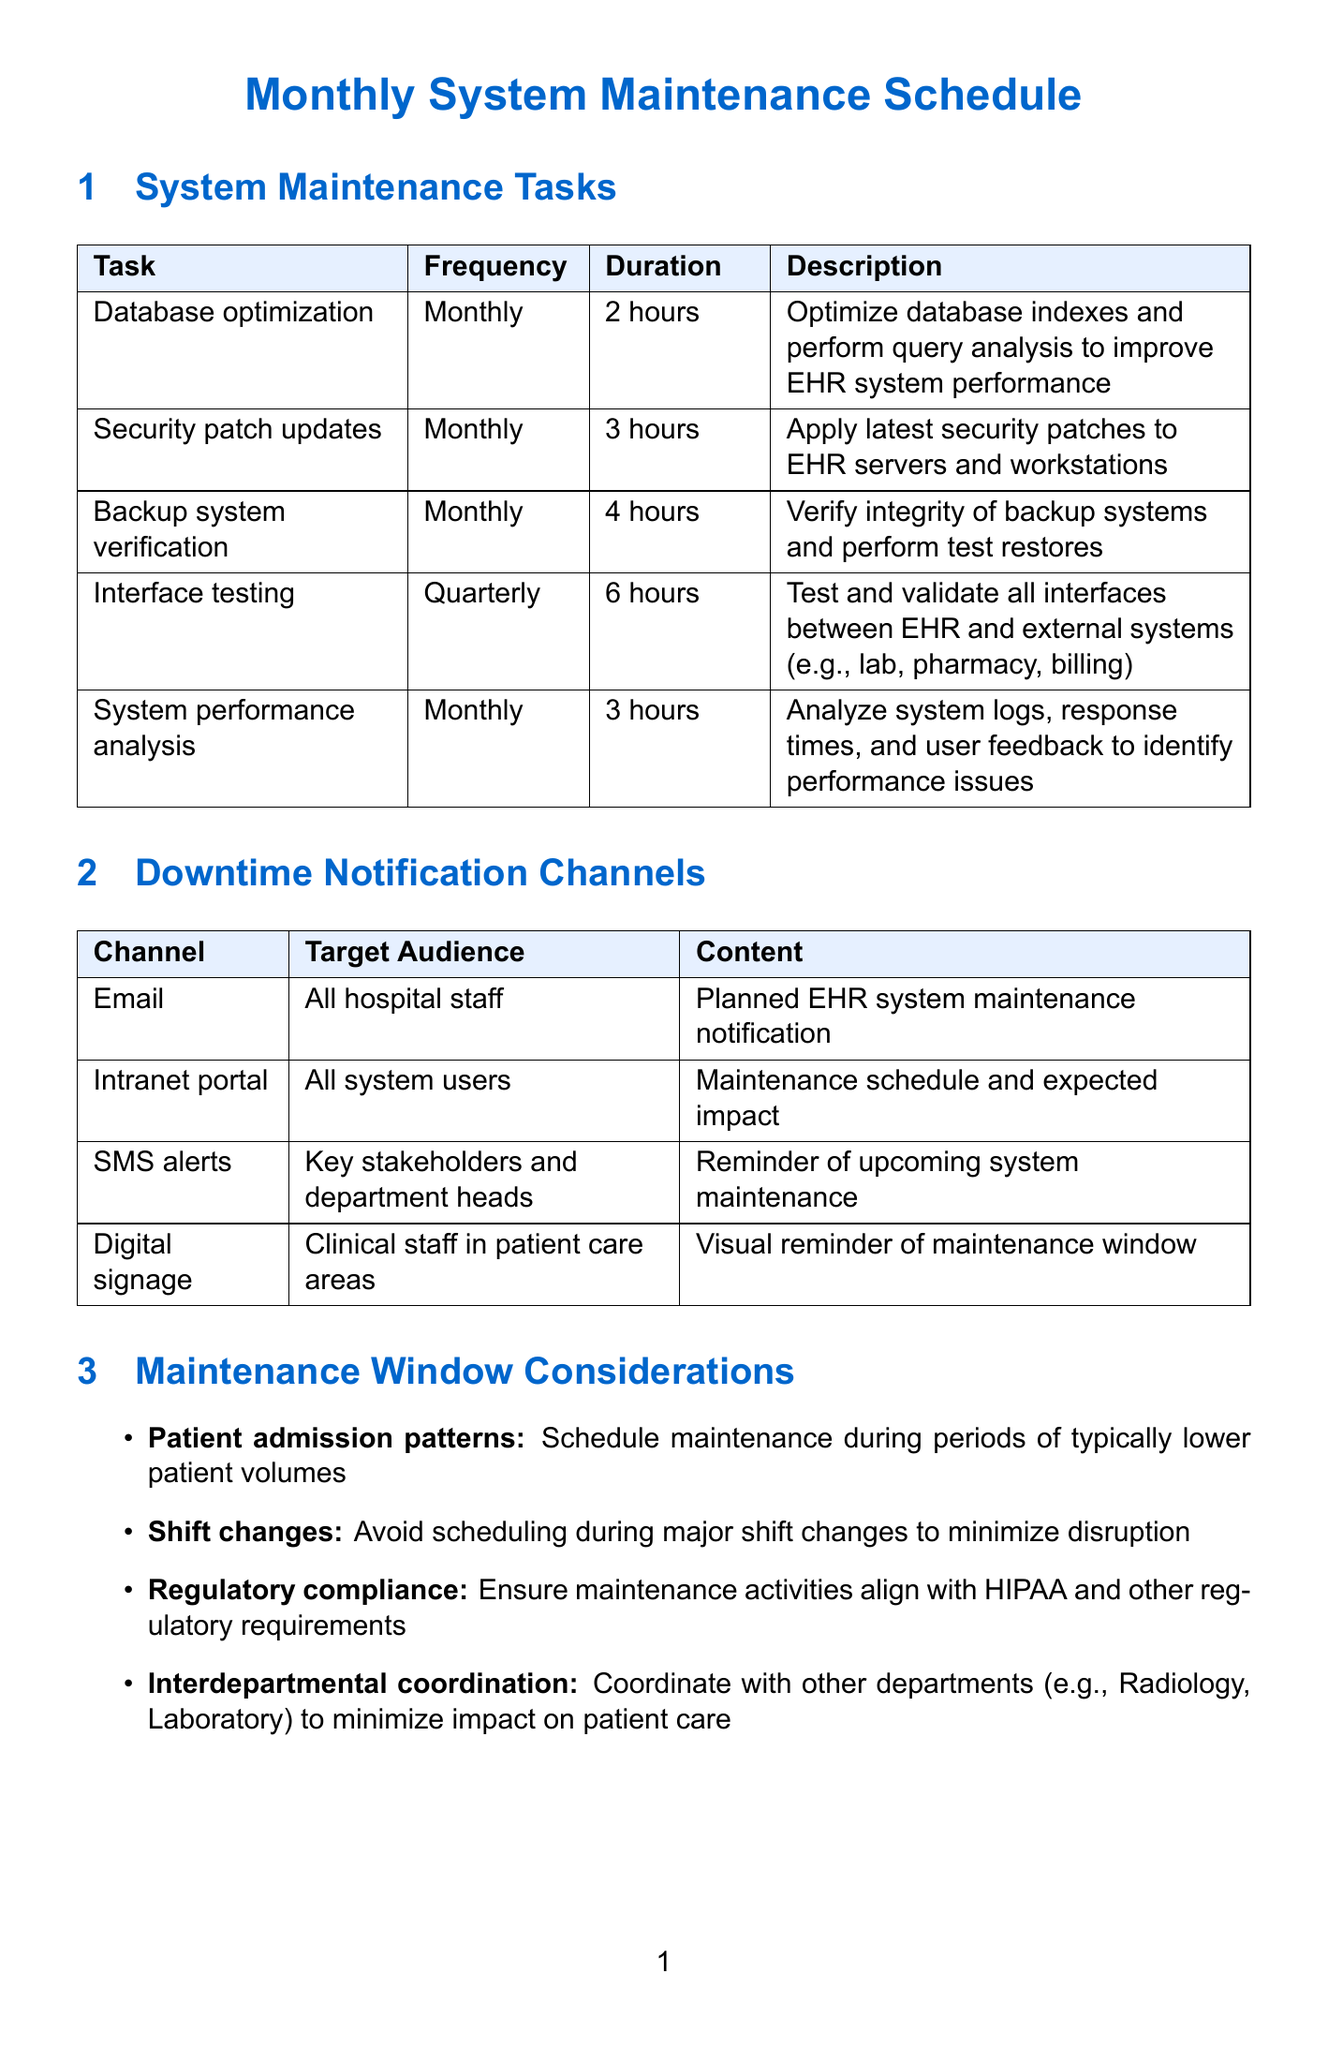what is the duration of the database optimization task? The duration for the database optimization task is specified in the document under system maintenance tasks.
Answer: 2 hours who is responsible for security patch updates? The document indicates the responsible team for security patch updates in the system maintenance tasks section.
Answer: IT Security what is the notification time for backup system verification? The notification time is mentioned in the context of the backup system verification task.
Answer: 48 hours in advance how often is system performance analysis performed? The frequency is stated in the maintenance schedule under system maintenance tasks.
Answer: Monthly which channel is used for reminders to key stakeholders? The document lists various notification channels along with their target audiences.
Answer: SMS alerts what consideration involves avoiding major shift changes? The maintenance window considerations section outlines factors to consider when scheduling maintenance.
Answer: Shift changes how long does interface testing take? The duration for interface testing is noted in the system maintenance tasks section.
Answer: 6 hours what activity involves sending an all-clear message to users? This is mentioned in the post-maintenance activities of the document.
Answer: User notification what is the frequency of the backup system verification? The frequency for the backup system verification task is listed in the document.
Answer: Monthly 